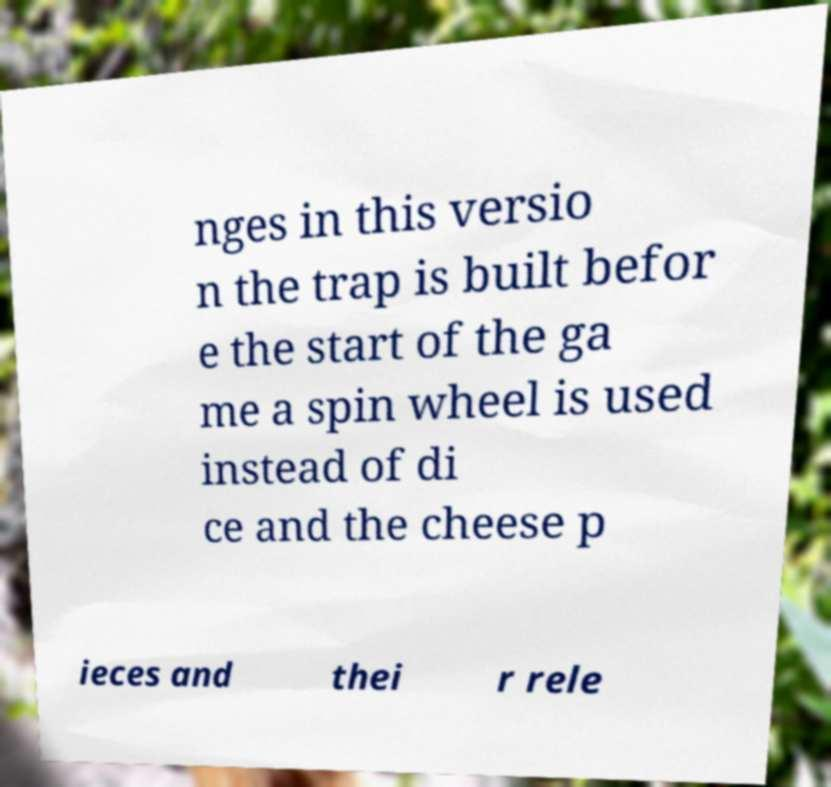For documentation purposes, I need the text within this image transcribed. Could you provide that? nges in this versio n the trap is built befor e the start of the ga me a spin wheel is used instead of di ce and the cheese p ieces and thei r rele 